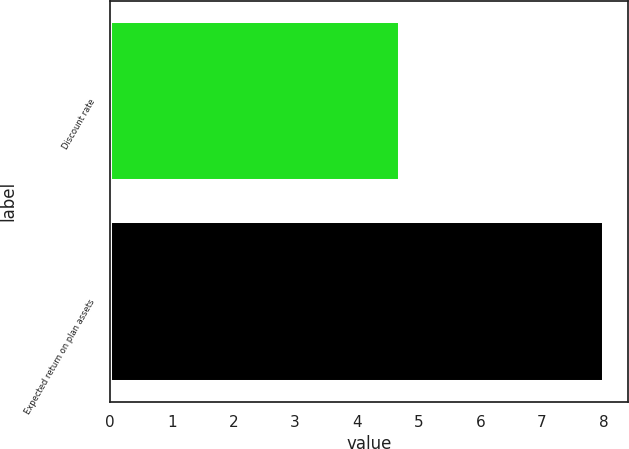<chart> <loc_0><loc_0><loc_500><loc_500><bar_chart><fcel>Discount rate<fcel>Expected return on plan assets<nl><fcel>4.7<fcel>8<nl></chart> 